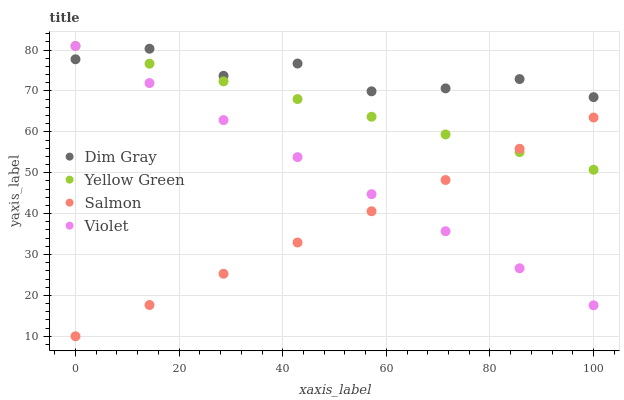Does Salmon have the minimum area under the curve?
Answer yes or no. Yes. Does Dim Gray have the maximum area under the curve?
Answer yes or no. Yes. Does Yellow Green have the minimum area under the curve?
Answer yes or no. No. Does Yellow Green have the maximum area under the curve?
Answer yes or no. No. Is Yellow Green the smoothest?
Answer yes or no. Yes. Is Dim Gray the roughest?
Answer yes or no. Yes. Is Salmon the smoothest?
Answer yes or no. No. Is Salmon the roughest?
Answer yes or no. No. Does Salmon have the lowest value?
Answer yes or no. Yes. Does Yellow Green have the lowest value?
Answer yes or no. No. Does Violet have the highest value?
Answer yes or no. Yes. Does Salmon have the highest value?
Answer yes or no. No. Is Salmon less than Dim Gray?
Answer yes or no. Yes. Is Dim Gray greater than Salmon?
Answer yes or no. Yes. Does Violet intersect Salmon?
Answer yes or no. Yes. Is Violet less than Salmon?
Answer yes or no. No. Is Violet greater than Salmon?
Answer yes or no. No. Does Salmon intersect Dim Gray?
Answer yes or no. No. 